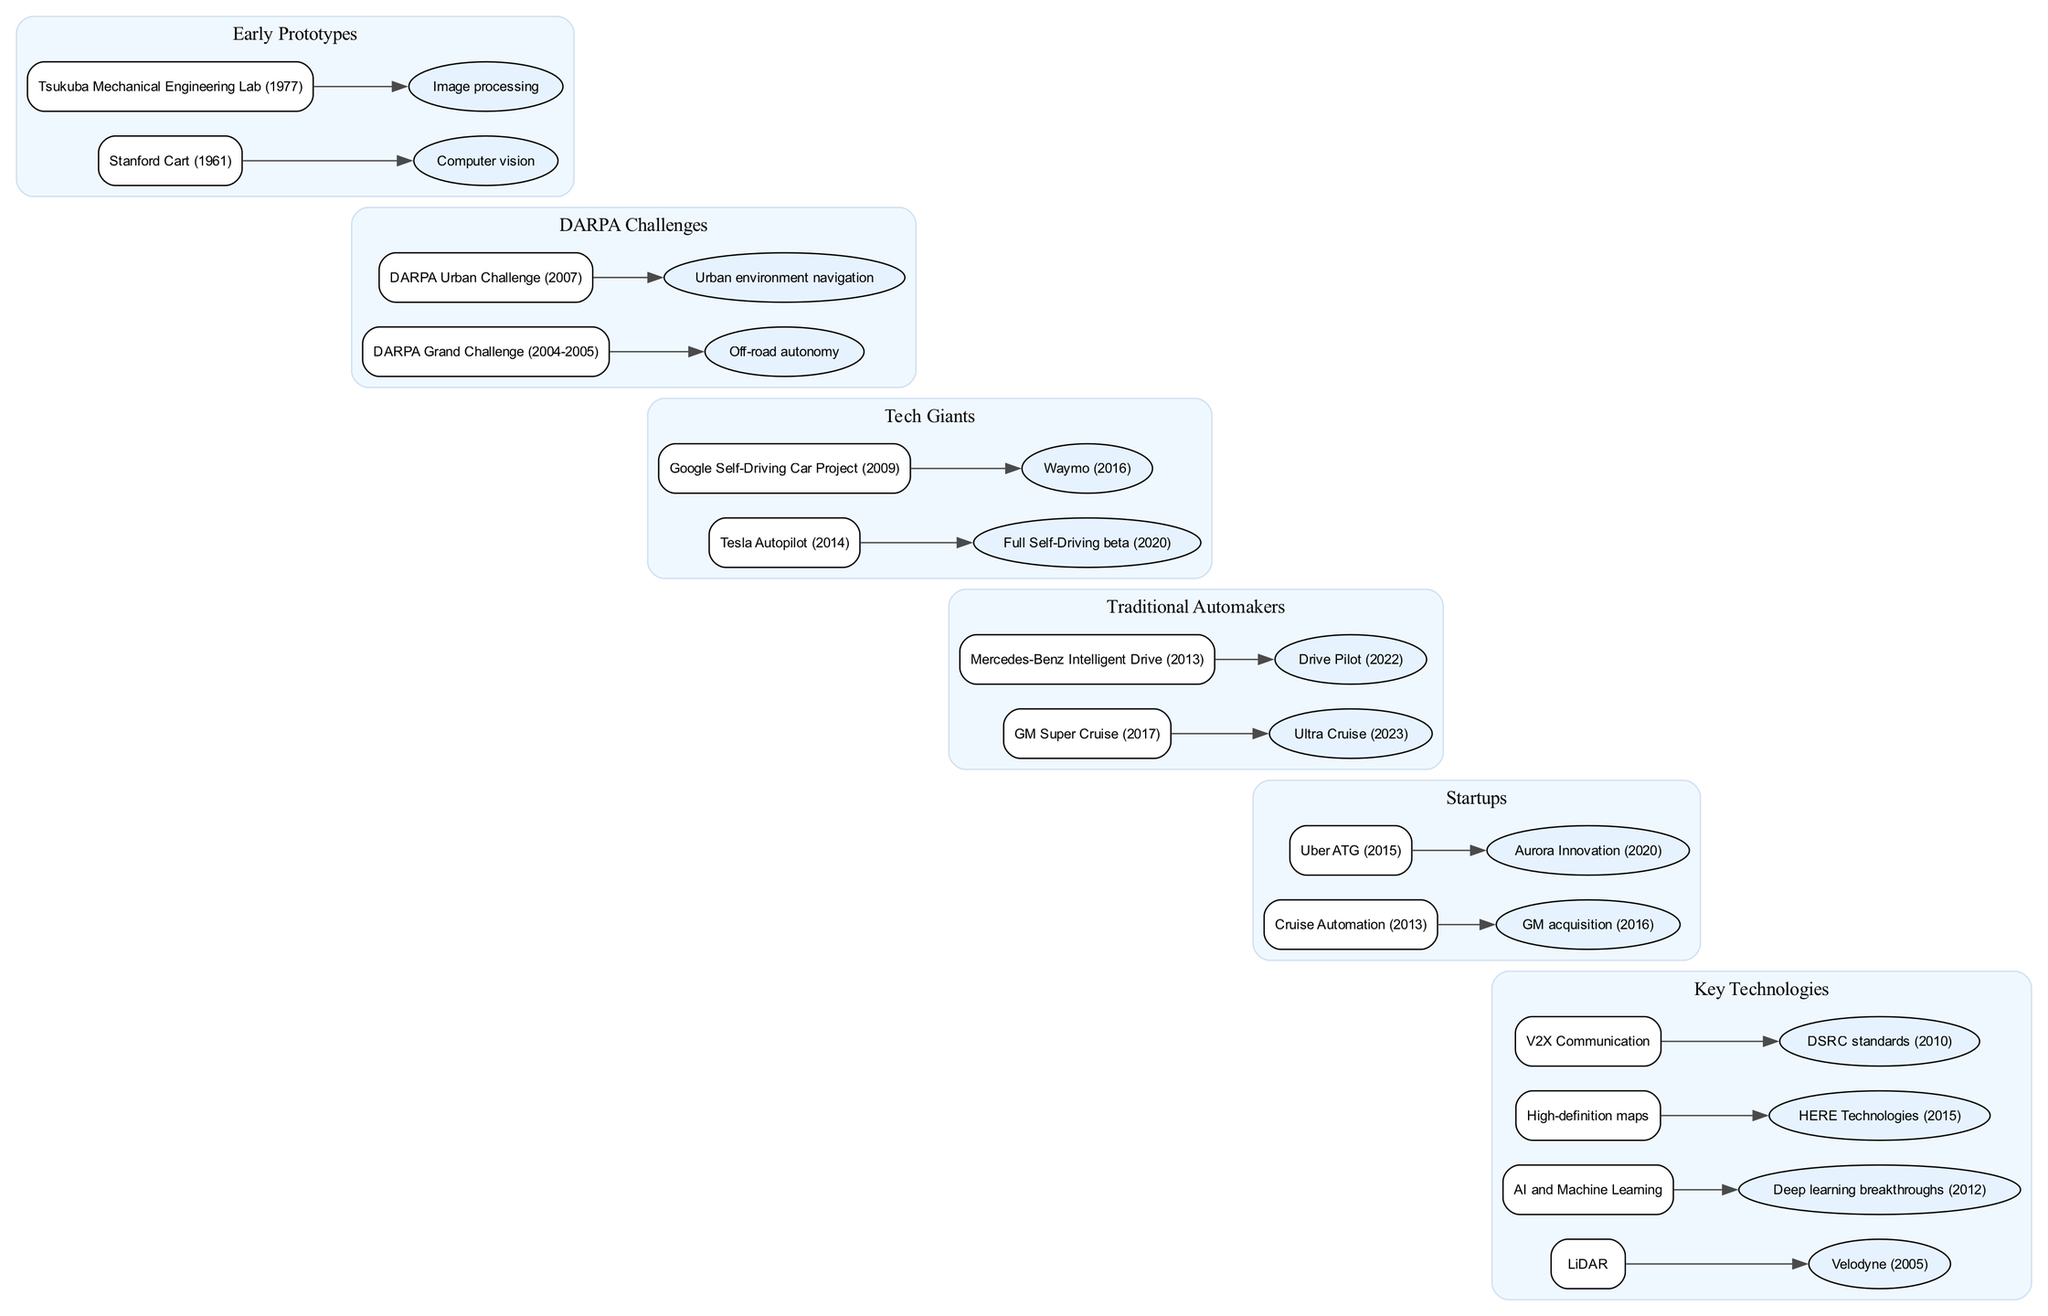What is the earliest self-driving car prototype listed in the diagram? The diagram shows "Stanford Cart (1961)" as the earliest prototype in the "Early Prototypes" section. By identifying the first item in that category, I can conclude that it represents the starting point of self-driving car technology.
Answer: Stanford Cart (1961) How many nodes are present in the "DARPA Challenges" category? The "DARPA Challenges" section contains two nodes: "DARPA Grand Challenge (2004-2005)" and "DARPA Urban Challenge (2007)." Counting these provides the total nodes related to DARPA.
Answer: 2 Which company is associated with the "Waymo (2016)" node? In the diagram, "Waymo (2016)" is linked to "Google Self-Driving Car Project (2009)" in the "Tech Giants" section. By following the line from the project node to the associated company, I find that Waymo is derived from the Google initiative.
Answer: Google What year did the "Tesla Autopilot" launch? The diagram indicates that "Tesla Autopilot" was introduced in "2014." By reading directly from the node, I can directly determine the launch year without further computation.
Answer: 2014 Which technology is connected to "Deep learning breakthroughs"? The "AI and Machine Learning" node in the "Key Technologies" category is connected to "Deep learning breakthroughs (2012)." This connection indicates the relationship between these technologies, leading me to the correct answer.
Answer: AI and Machine Learning Which technology was first developed in 2010? The diagram shows "DSRC standards (2010)" under the "V2X Communication" node in the "Key Technologies" section. Identifying the year from the description allows me to confirm the date of development for this technology.
Answer: 2010 What type of technology is "Velodyne"? "Velodyne (2005)" is listed under the "LiDAR" node in the "Key Technologies" section. By analyzing the connection, it's clear that Velodyne is associated with LiDAR technology in the timeline.
Answer: LiDAR Which accelerator company was acquired by GM in 2016? The diagram states "Cruise Automation (2013)" was acquired by GM in "2016." By following the connection from the start-up node to the company acquisition node, I identify the exact relationship and date of the acquisition.
Answer: Cruise Automation Which self-driving technology first became available in 2022? The node shows "Drive Pilot (2022)" under "Mercedes-Benz Intelligent Drive (2013)." This placement indicates the year of availability for this specific driving technology, making it easily identifiable in the timeline.
Answer: Drive Pilot (2022) 